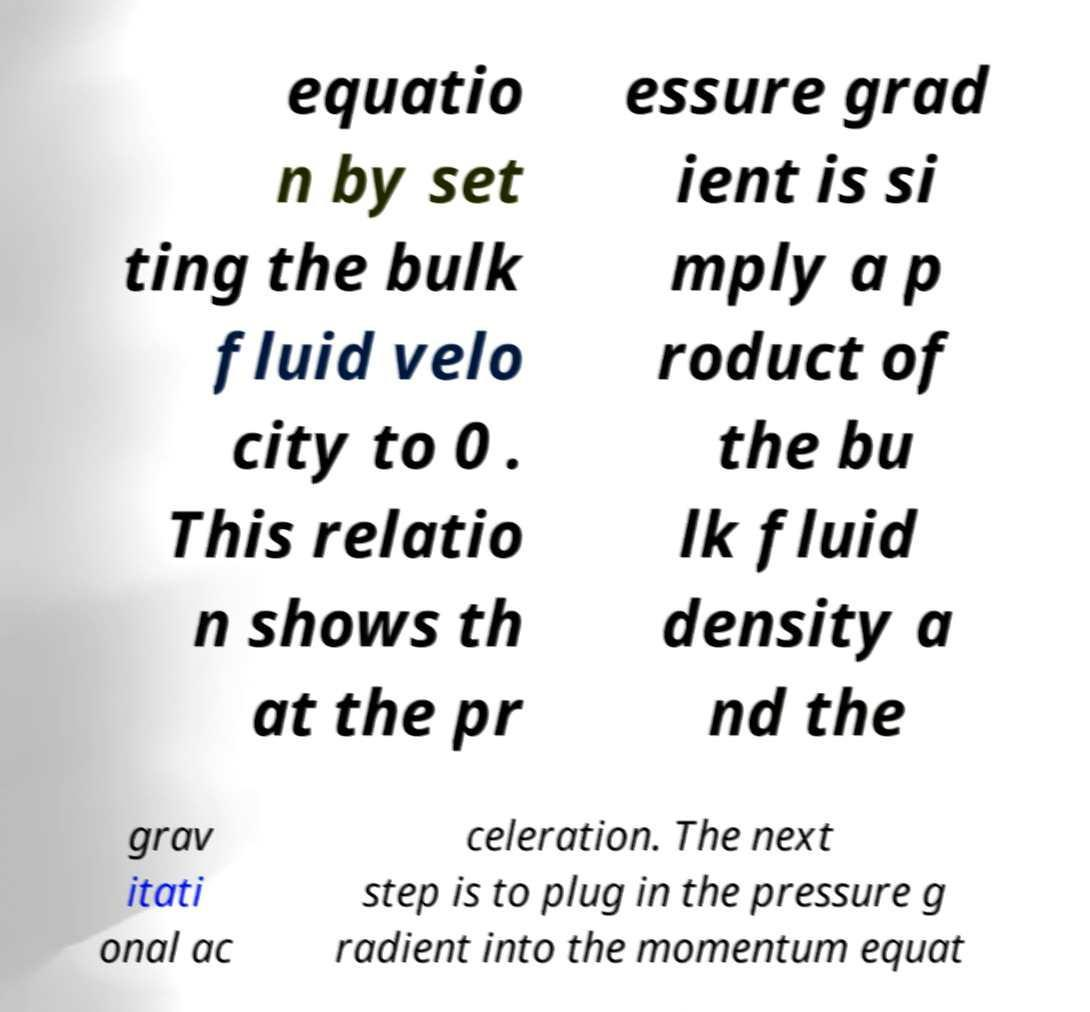There's text embedded in this image that I need extracted. Can you transcribe it verbatim? equatio n by set ting the bulk fluid velo city to 0 . This relatio n shows th at the pr essure grad ient is si mply a p roduct of the bu lk fluid density a nd the grav itati onal ac celeration. The next step is to plug in the pressure g radient into the momentum equat 